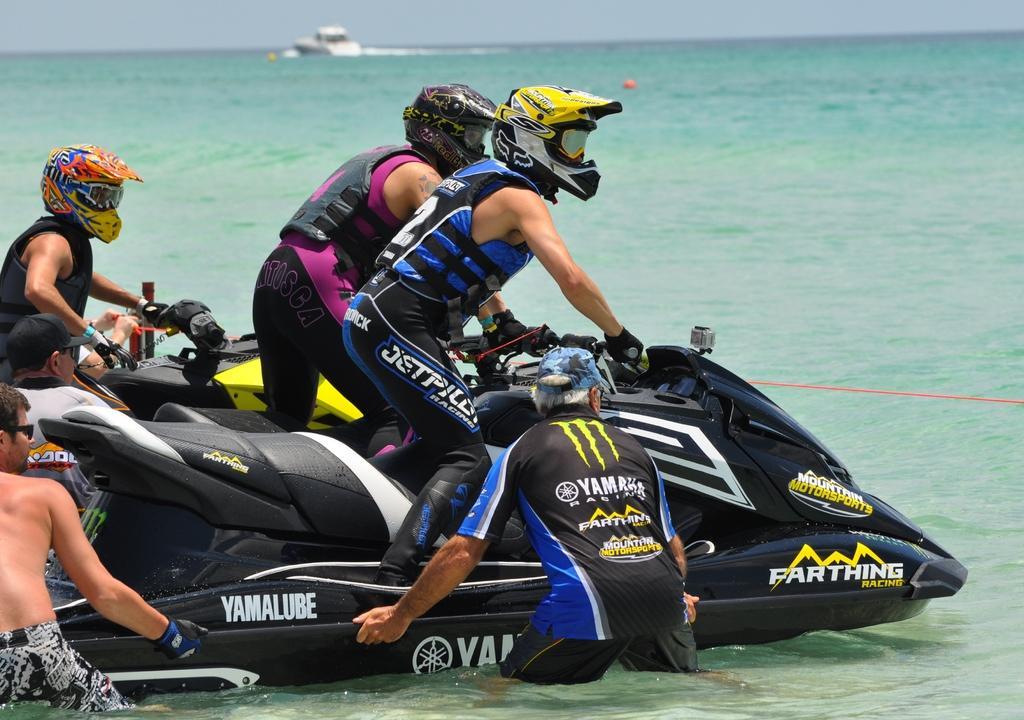In one or two sentences, can you explain what this image depicts? There are persons in different color dresses riding boats on the water of an ocean near two persons who are holding the boat. In the background, there is a white color boat on the water and there is sky. 